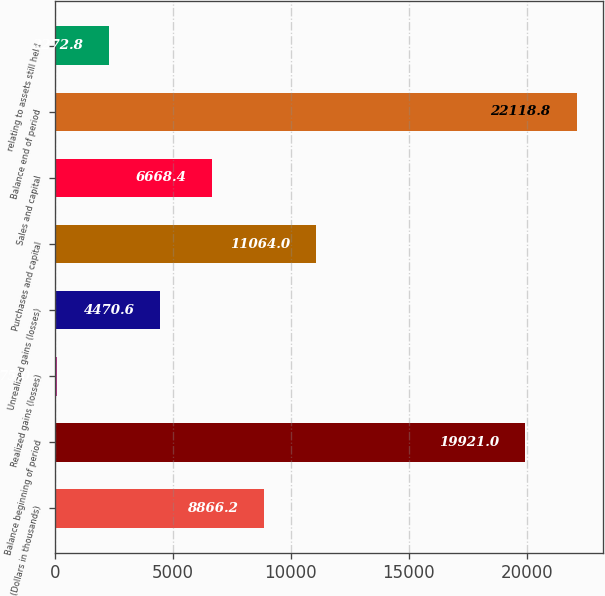Convert chart. <chart><loc_0><loc_0><loc_500><loc_500><bar_chart><fcel>(Dollars in thousands)<fcel>Balance beginning of period<fcel>Realized gains (losses)<fcel>Unrealized gains (losses)<fcel>Purchases and capital<fcel>Sales and capital<fcel>Balance end of period<fcel>relating to assets still held<nl><fcel>8866.2<fcel>19921<fcel>75<fcel>4470.6<fcel>11064<fcel>6668.4<fcel>22118.8<fcel>2272.8<nl></chart> 